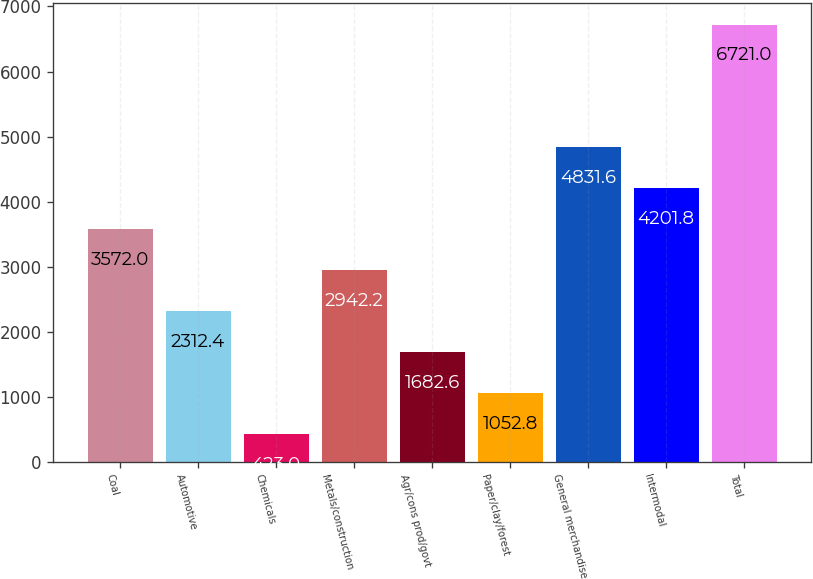<chart> <loc_0><loc_0><loc_500><loc_500><bar_chart><fcel>Coal<fcel>Automotive<fcel>Chemicals<fcel>Metals/construction<fcel>Agr/cons prod/govt<fcel>Paper/clay/forest<fcel>General merchandise<fcel>Intermodal<fcel>Total<nl><fcel>3572<fcel>2312.4<fcel>423<fcel>2942.2<fcel>1682.6<fcel>1052.8<fcel>4831.6<fcel>4201.8<fcel>6721<nl></chart> 